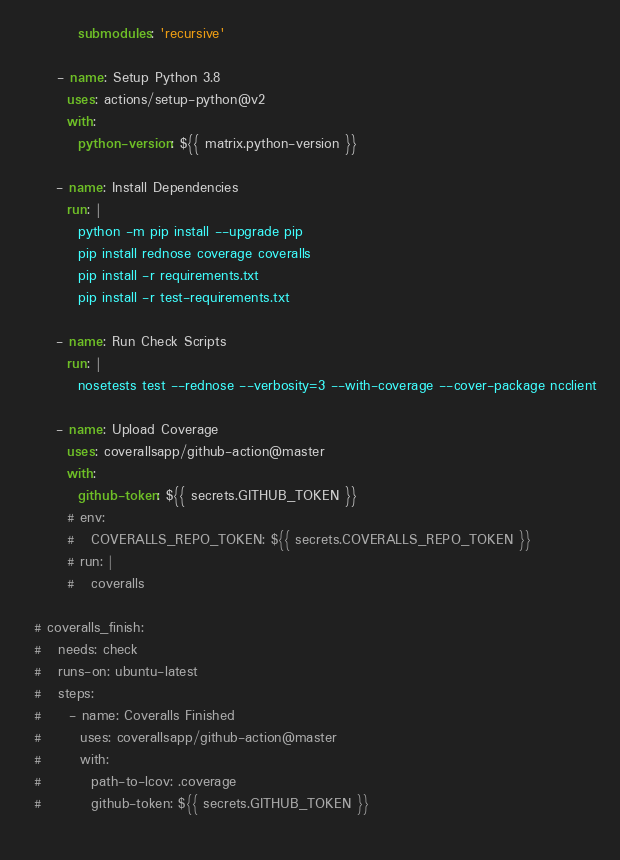Convert code to text. <code><loc_0><loc_0><loc_500><loc_500><_YAML_>          submodules: 'recursive'

      - name: Setup Python 3.8
        uses: actions/setup-python@v2
        with:
          python-version: ${{ matrix.python-version }}

      - name: Install Dependencies
        run: |
          python -m pip install --upgrade pip
          pip install rednose coverage coveralls
          pip install -r requirements.txt
          pip install -r test-requirements.txt

      - name: Run Check Scripts
        run: |
          nosetests test --rednose --verbosity=3 --with-coverage --cover-package ncclient

      - name: Upload Coverage
        uses: coverallsapp/github-action@master
        with:
          github-token: ${{ secrets.GITHUB_TOKEN }}
        # env:
        #   COVERALLS_REPO_TOKEN: ${{ secrets.COVERALLS_REPO_TOKEN }}
        # run: |
        #   coveralls

  # coveralls_finish:
  #   needs: check
  #   runs-on: ubuntu-latest
  #   steps:
  #     - name: Coveralls Finished
  #       uses: coverallsapp/github-action@master
  #       with:
  #         path-to-lcov: .coverage
  #         github-token: ${{ secrets.GITHUB_TOKEN }}
  
</code> 